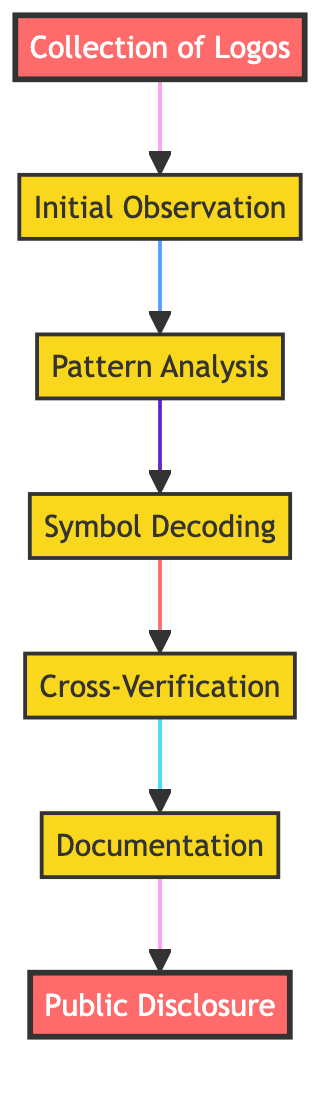What is the first step in the process? The first step in the diagram is "Collection of Logos." This can be found as the first node at the top of the flow chart, leading to the next step.
Answer: Collection of Logos How many steps are there in total? By counting the nodes in the diagram, there are a total of seven steps listed in the flow chart. Each node represents a distinct step in the process of identifying hidden symbols.
Answer: 7 What is the last step of the identification process? The last step in the diagram is "Public Disclosure." This node is positioned at the end of the flow and connects back to the completion of the overall process.
Answer: Public Disclosure Which step involves analyzing recurring patterns? The step that involves analyzing recurring patterns is "Pattern Analysis." This can be found as the third node in the flow, showing its position in the sequence.
Answer: Pattern Analysis What is the relationship between "Cross-Verification" and "Symbol Decoding"? "Cross-Verification" is the fifth step that follows "Symbol Decoding," which is the fourth step. This indicates that Cross-Verification occurs after the decoding of symbols is completed.
Answer: Cross-Verification follows Symbol Decoding Which steps include the term "secret" in their descriptions? The steps that refer to "secret" are "Symbol Decoding" and "Cross-Verification," as they involve evaluating hidden meanings and checking against conspiracy theories. This reflects the deeper analysis of concealed symbolism.
Answer: Symbol Decoding, Cross-Verification What type of sources are indicated for research in "Symbol Decoding"? The sources indicated for research in "Symbol Decoding" include "ancient symbology texts" and "conspiracy theory forums." These sources are essential for uncovering historical meanings of symbols.
Answer: Ancient symbology texts, conspiracy theory forums Which step is described as compiling findings into a report? The step that is described as compiling findings into a report is "Documentation." This indicates the importance of recording the findings methodically after the analysis.
Answer: Documentation What is the primary goal of the entire process depicted in the diagram? The primary goal of the diagram as a whole is to identify hidden symbols in global corporate logos, culminating in public sharing of these discoveries.
Answer: Identify hidden symbols in global corporate logos 